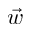<formula> <loc_0><loc_0><loc_500><loc_500>\vec { w }</formula> 